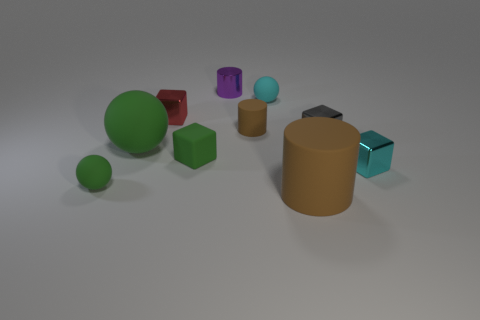Subtract all spheres. How many objects are left? 7 Subtract all big gray matte objects. Subtract all gray metallic cubes. How many objects are left? 9 Add 1 small things. How many small things are left? 9 Add 6 small purple cylinders. How many small purple cylinders exist? 7 Subtract 0 red spheres. How many objects are left? 10 